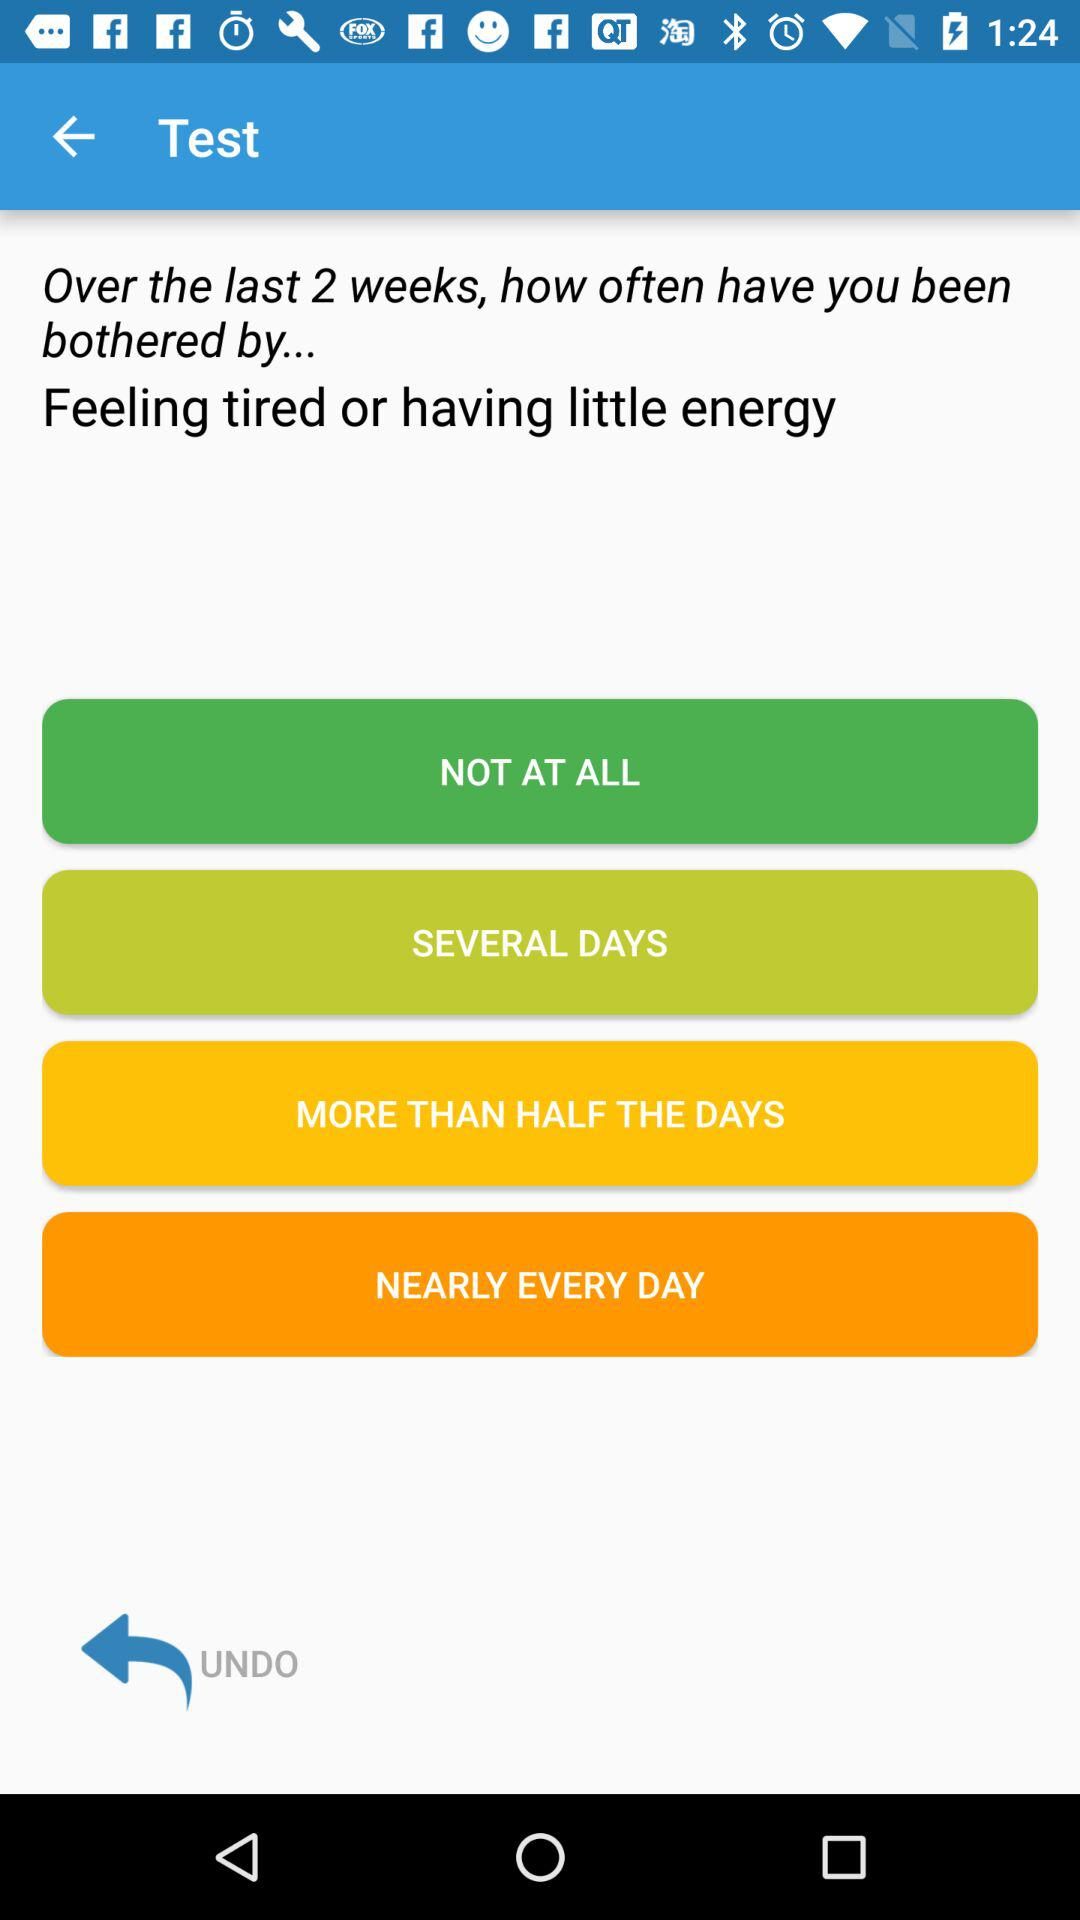How many options are there to answer the question?
Answer the question using a single word or phrase. 4 